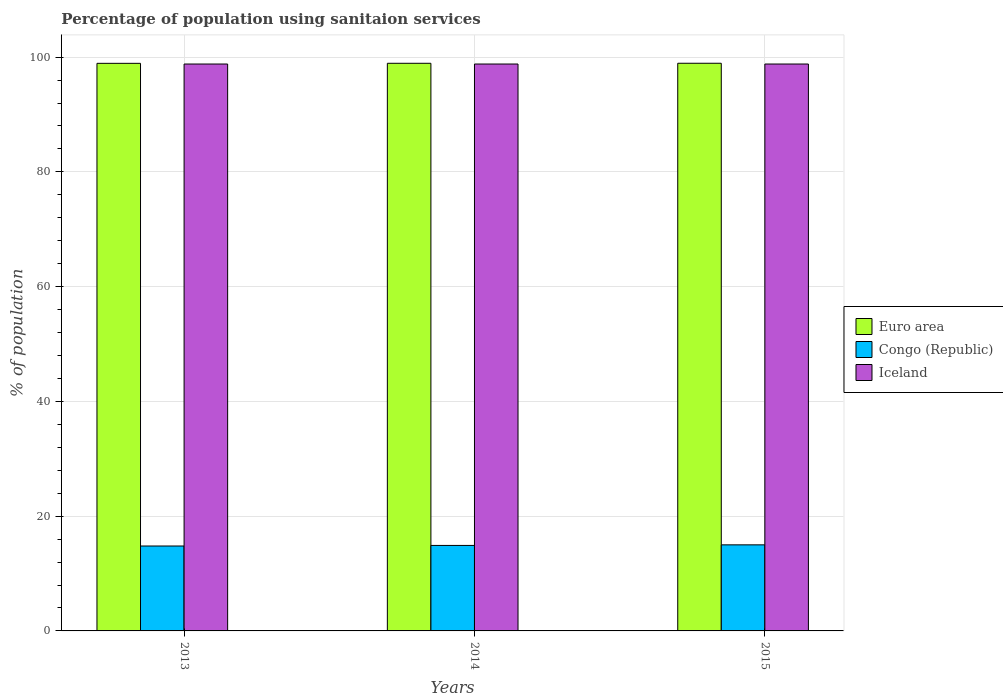How many bars are there on the 2nd tick from the left?
Provide a succinct answer. 3. How many bars are there on the 2nd tick from the right?
Give a very brief answer. 3. What is the label of the 3rd group of bars from the left?
Your answer should be compact. 2015. In how many cases, is the number of bars for a given year not equal to the number of legend labels?
Make the answer very short. 0. What is the percentage of population using sanitaion services in Euro area in 2014?
Keep it short and to the point. 98.93. Across all years, what is the maximum percentage of population using sanitaion services in Iceland?
Provide a succinct answer. 98.8. Across all years, what is the minimum percentage of population using sanitaion services in Iceland?
Offer a terse response. 98.8. In which year was the percentage of population using sanitaion services in Euro area maximum?
Give a very brief answer. 2015. In which year was the percentage of population using sanitaion services in Congo (Republic) minimum?
Make the answer very short. 2013. What is the total percentage of population using sanitaion services in Iceland in the graph?
Offer a very short reply. 296.4. What is the difference between the percentage of population using sanitaion services in Congo (Republic) in 2014 and that in 2015?
Offer a very short reply. -0.1. What is the difference between the percentage of population using sanitaion services in Euro area in 2015 and the percentage of population using sanitaion services in Iceland in 2014?
Ensure brevity in your answer.  0.13. What is the average percentage of population using sanitaion services in Euro area per year?
Your response must be concise. 98.93. In the year 2014, what is the difference between the percentage of population using sanitaion services in Iceland and percentage of population using sanitaion services in Euro area?
Provide a succinct answer. -0.13. What is the ratio of the percentage of population using sanitaion services in Congo (Republic) in 2013 to that in 2015?
Give a very brief answer. 0.99. Is the percentage of population using sanitaion services in Congo (Republic) in 2013 less than that in 2015?
Your response must be concise. Yes. What is the difference between the highest and the second highest percentage of population using sanitaion services in Euro area?
Ensure brevity in your answer.  0.01. What is the difference between the highest and the lowest percentage of population using sanitaion services in Euro area?
Make the answer very short. 0.01. Is the sum of the percentage of population using sanitaion services in Iceland in 2014 and 2015 greater than the maximum percentage of population using sanitaion services in Congo (Republic) across all years?
Provide a short and direct response. Yes. How many bars are there?
Give a very brief answer. 9. Are all the bars in the graph horizontal?
Ensure brevity in your answer.  No. How many years are there in the graph?
Offer a very short reply. 3. What is the difference between two consecutive major ticks on the Y-axis?
Make the answer very short. 20. Are the values on the major ticks of Y-axis written in scientific E-notation?
Your answer should be very brief. No. How many legend labels are there?
Your response must be concise. 3. How are the legend labels stacked?
Your response must be concise. Vertical. What is the title of the graph?
Offer a terse response. Percentage of population using sanitaion services. Does "Senegal" appear as one of the legend labels in the graph?
Your answer should be compact. No. What is the label or title of the X-axis?
Your answer should be very brief. Years. What is the label or title of the Y-axis?
Offer a terse response. % of population. What is the % of population in Euro area in 2013?
Offer a terse response. 98.92. What is the % of population of Iceland in 2013?
Provide a succinct answer. 98.8. What is the % of population of Euro area in 2014?
Keep it short and to the point. 98.93. What is the % of population of Iceland in 2014?
Make the answer very short. 98.8. What is the % of population of Euro area in 2015?
Keep it short and to the point. 98.93. What is the % of population of Congo (Republic) in 2015?
Offer a terse response. 15. What is the % of population in Iceland in 2015?
Provide a succinct answer. 98.8. Across all years, what is the maximum % of population of Euro area?
Offer a very short reply. 98.93. Across all years, what is the maximum % of population of Congo (Republic)?
Ensure brevity in your answer.  15. Across all years, what is the maximum % of population of Iceland?
Ensure brevity in your answer.  98.8. Across all years, what is the minimum % of population of Euro area?
Provide a short and direct response. 98.92. Across all years, what is the minimum % of population of Congo (Republic)?
Your response must be concise. 14.8. Across all years, what is the minimum % of population of Iceland?
Ensure brevity in your answer.  98.8. What is the total % of population in Euro area in the graph?
Make the answer very short. 296.78. What is the total % of population in Congo (Republic) in the graph?
Your response must be concise. 44.7. What is the total % of population in Iceland in the graph?
Give a very brief answer. 296.4. What is the difference between the % of population in Euro area in 2013 and that in 2014?
Offer a terse response. -0.01. What is the difference between the % of population in Euro area in 2013 and that in 2015?
Offer a very short reply. -0.01. What is the difference between the % of population in Congo (Republic) in 2013 and that in 2015?
Provide a short and direct response. -0.2. What is the difference between the % of population in Iceland in 2013 and that in 2015?
Provide a succinct answer. 0. What is the difference between the % of population of Euro area in 2014 and that in 2015?
Keep it short and to the point. -0.01. What is the difference between the % of population in Congo (Republic) in 2014 and that in 2015?
Your answer should be compact. -0.1. What is the difference between the % of population in Iceland in 2014 and that in 2015?
Your answer should be compact. 0. What is the difference between the % of population of Euro area in 2013 and the % of population of Congo (Republic) in 2014?
Ensure brevity in your answer.  84.02. What is the difference between the % of population in Euro area in 2013 and the % of population in Iceland in 2014?
Provide a short and direct response. 0.12. What is the difference between the % of population in Congo (Republic) in 2013 and the % of population in Iceland in 2014?
Keep it short and to the point. -84. What is the difference between the % of population in Euro area in 2013 and the % of population in Congo (Republic) in 2015?
Offer a terse response. 83.92. What is the difference between the % of population of Euro area in 2013 and the % of population of Iceland in 2015?
Your answer should be compact. 0.12. What is the difference between the % of population of Congo (Republic) in 2013 and the % of population of Iceland in 2015?
Your response must be concise. -84. What is the difference between the % of population in Euro area in 2014 and the % of population in Congo (Republic) in 2015?
Give a very brief answer. 83.93. What is the difference between the % of population of Euro area in 2014 and the % of population of Iceland in 2015?
Give a very brief answer. 0.13. What is the difference between the % of population in Congo (Republic) in 2014 and the % of population in Iceland in 2015?
Your answer should be very brief. -83.9. What is the average % of population of Euro area per year?
Ensure brevity in your answer.  98.93. What is the average % of population of Iceland per year?
Ensure brevity in your answer.  98.8. In the year 2013, what is the difference between the % of population in Euro area and % of population in Congo (Republic)?
Your answer should be very brief. 84.12. In the year 2013, what is the difference between the % of population in Euro area and % of population in Iceland?
Provide a succinct answer. 0.12. In the year 2013, what is the difference between the % of population of Congo (Republic) and % of population of Iceland?
Offer a very short reply. -84. In the year 2014, what is the difference between the % of population in Euro area and % of population in Congo (Republic)?
Ensure brevity in your answer.  84.03. In the year 2014, what is the difference between the % of population of Euro area and % of population of Iceland?
Give a very brief answer. 0.13. In the year 2014, what is the difference between the % of population of Congo (Republic) and % of population of Iceland?
Ensure brevity in your answer.  -83.9. In the year 2015, what is the difference between the % of population of Euro area and % of population of Congo (Republic)?
Offer a very short reply. 83.93. In the year 2015, what is the difference between the % of population of Euro area and % of population of Iceland?
Give a very brief answer. 0.13. In the year 2015, what is the difference between the % of population in Congo (Republic) and % of population in Iceland?
Your answer should be very brief. -83.8. What is the ratio of the % of population in Euro area in 2013 to that in 2014?
Your answer should be very brief. 1. What is the ratio of the % of population in Congo (Republic) in 2013 to that in 2015?
Your response must be concise. 0.99. What is the ratio of the % of population of Iceland in 2013 to that in 2015?
Give a very brief answer. 1. What is the ratio of the % of population in Congo (Republic) in 2014 to that in 2015?
Provide a succinct answer. 0.99. What is the difference between the highest and the second highest % of population in Euro area?
Keep it short and to the point. 0.01. What is the difference between the highest and the lowest % of population in Euro area?
Provide a short and direct response. 0.01. What is the difference between the highest and the lowest % of population in Congo (Republic)?
Offer a terse response. 0.2. What is the difference between the highest and the lowest % of population in Iceland?
Offer a very short reply. 0. 